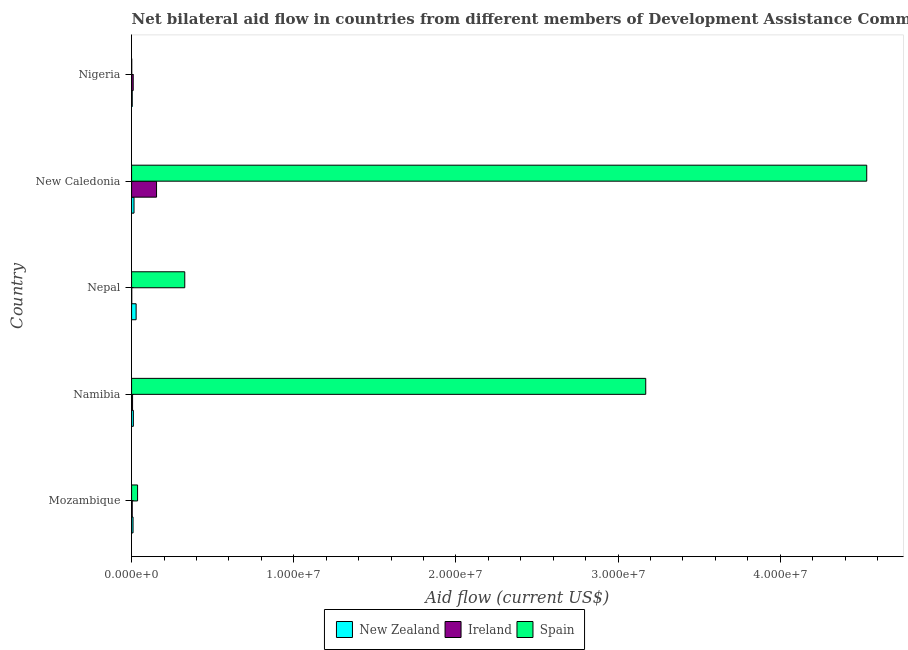How many groups of bars are there?
Your answer should be very brief. 5. What is the label of the 2nd group of bars from the top?
Give a very brief answer. New Caledonia. In how many cases, is the number of bars for a given country not equal to the number of legend labels?
Provide a short and direct response. 0. What is the amount of aid provided by spain in Mozambique?
Your answer should be compact. 3.70e+05. Across all countries, what is the maximum amount of aid provided by spain?
Ensure brevity in your answer.  4.53e+07. Across all countries, what is the minimum amount of aid provided by spain?
Keep it short and to the point. 10000. In which country was the amount of aid provided by ireland maximum?
Your answer should be compact. New Caledonia. In which country was the amount of aid provided by new zealand minimum?
Provide a succinct answer. Nigeria. What is the total amount of aid provided by spain in the graph?
Ensure brevity in your answer.  8.07e+07. What is the difference between the amount of aid provided by spain in Namibia and that in Nepal?
Give a very brief answer. 2.84e+07. What is the difference between the amount of aid provided by ireland in Nigeria and the amount of aid provided by new zealand in Namibia?
Make the answer very short. -10000. What is the average amount of aid provided by ireland per country?
Your answer should be compact. 3.50e+05. What is the difference between the amount of aid provided by ireland and amount of aid provided by new zealand in New Caledonia?
Make the answer very short. 1.39e+06. In how many countries, is the amount of aid provided by ireland greater than 20000000 US$?
Give a very brief answer. 0. Is the amount of aid provided by ireland in Mozambique less than that in Nigeria?
Your answer should be very brief. Yes. What is the difference between the highest and the lowest amount of aid provided by new zealand?
Keep it short and to the point. 2.40e+05. In how many countries, is the amount of aid provided by ireland greater than the average amount of aid provided by ireland taken over all countries?
Offer a very short reply. 1. Is the sum of the amount of aid provided by spain in Nepal and Nigeria greater than the maximum amount of aid provided by ireland across all countries?
Make the answer very short. Yes. What does the 3rd bar from the bottom in Nepal represents?
Your answer should be compact. Spain. How many bars are there?
Make the answer very short. 15. Are all the bars in the graph horizontal?
Give a very brief answer. Yes. Are the values on the major ticks of X-axis written in scientific E-notation?
Keep it short and to the point. Yes. Does the graph contain any zero values?
Give a very brief answer. No. Does the graph contain grids?
Ensure brevity in your answer.  No. Where does the legend appear in the graph?
Your answer should be very brief. Bottom center. What is the title of the graph?
Ensure brevity in your answer.  Net bilateral aid flow in countries from different members of Development Assistance Committee. What is the Aid flow (current US$) of Ireland in Mozambique?
Make the answer very short. 4.00e+04. What is the Aid flow (current US$) in Spain in Namibia?
Offer a terse response. 3.17e+07. What is the Aid flow (current US$) in Spain in Nepal?
Offer a very short reply. 3.28e+06. What is the Aid flow (current US$) of Ireland in New Caledonia?
Offer a terse response. 1.54e+06. What is the Aid flow (current US$) in Spain in New Caledonia?
Provide a short and direct response. 4.53e+07. What is the Aid flow (current US$) of Spain in Nigeria?
Ensure brevity in your answer.  10000. Across all countries, what is the maximum Aid flow (current US$) in New Zealand?
Offer a terse response. 2.80e+05. Across all countries, what is the maximum Aid flow (current US$) of Ireland?
Offer a very short reply. 1.54e+06. Across all countries, what is the maximum Aid flow (current US$) in Spain?
Offer a very short reply. 4.53e+07. Across all countries, what is the minimum Aid flow (current US$) of Spain?
Your response must be concise. 10000. What is the total Aid flow (current US$) in New Zealand in the graph?
Offer a terse response. 6.70e+05. What is the total Aid flow (current US$) of Ireland in the graph?
Your answer should be very brief. 1.75e+06. What is the total Aid flow (current US$) in Spain in the graph?
Provide a short and direct response. 8.07e+07. What is the difference between the Aid flow (current US$) of Spain in Mozambique and that in Namibia?
Offer a very short reply. -3.13e+07. What is the difference between the Aid flow (current US$) in Spain in Mozambique and that in Nepal?
Keep it short and to the point. -2.91e+06. What is the difference between the Aid flow (current US$) of Ireland in Mozambique and that in New Caledonia?
Offer a very short reply. -1.50e+06. What is the difference between the Aid flow (current US$) in Spain in Mozambique and that in New Caledonia?
Your answer should be very brief. -4.50e+07. What is the difference between the Aid flow (current US$) of New Zealand in Mozambique and that in Nigeria?
Your response must be concise. 5.00e+04. What is the difference between the Aid flow (current US$) of Ireland in Mozambique and that in Nigeria?
Your answer should be compact. -6.00e+04. What is the difference between the Aid flow (current US$) in New Zealand in Namibia and that in Nepal?
Your response must be concise. -1.70e+05. What is the difference between the Aid flow (current US$) of Spain in Namibia and that in Nepal?
Provide a succinct answer. 2.84e+07. What is the difference between the Aid flow (current US$) in Ireland in Namibia and that in New Caledonia?
Your response must be concise. -1.48e+06. What is the difference between the Aid flow (current US$) of Spain in Namibia and that in New Caledonia?
Ensure brevity in your answer.  -1.36e+07. What is the difference between the Aid flow (current US$) in New Zealand in Namibia and that in Nigeria?
Ensure brevity in your answer.  7.00e+04. What is the difference between the Aid flow (current US$) of Spain in Namibia and that in Nigeria?
Make the answer very short. 3.17e+07. What is the difference between the Aid flow (current US$) of Ireland in Nepal and that in New Caledonia?
Make the answer very short. -1.53e+06. What is the difference between the Aid flow (current US$) of Spain in Nepal and that in New Caledonia?
Give a very brief answer. -4.21e+07. What is the difference between the Aid flow (current US$) in Spain in Nepal and that in Nigeria?
Ensure brevity in your answer.  3.27e+06. What is the difference between the Aid flow (current US$) of New Zealand in New Caledonia and that in Nigeria?
Your answer should be very brief. 1.10e+05. What is the difference between the Aid flow (current US$) in Ireland in New Caledonia and that in Nigeria?
Keep it short and to the point. 1.44e+06. What is the difference between the Aid flow (current US$) of Spain in New Caledonia and that in Nigeria?
Provide a succinct answer. 4.53e+07. What is the difference between the Aid flow (current US$) of New Zealand in Mozambique and the Aid flow (current US$) of Ireland in Namibia?
Your response must be concise. 3.00e+04. What is the difference between the Aid flow (current US$) in New Zealand in Mozambique and the Aid flow (current US$) in Spain in Namibia?
Provide a short and direct response. -3.16e+07. What is the difference between the Aid flow (current US$) in Ireland in Mozambique and the Aid flow (current US$) in Spain in Namibia?
Make the answer very short. -3.17e+07. What is the difference between the Aid flow (current US$) of New Zealand in Mozambique and the Aid flow (current US$) of Ireland in Nepal?
Offer a terse response. 8.00e+04. What is the difference between the Aid flow (current US$) of New Zealand in Mozambique and the Aid flow (current US$) of Spain in Nepal?
Offer a very short reply. -3.19e+06. What is the difference between the Aid flow (current US$) of Ireland in Mozambique and the Aid flow (current US$) of Spain in Nepal?
Offer a very short reply. -3.24e+06. What is the difference between the Aid flow (current US$) in New Zealand in Mozambique and the Aid flow (current US$) in Ireland in New Caledonia?
Your answer should be compact. -1.45e+06. What is the difference between the Aid flow (current US$) of New Zealand in Mozambique and the Aid flow (current US$) of Spain in New Caledonia?
Provide a short and direct response. -4.52e+07. What is the difference between the Aid flow (current US$) in Ireland in Mozambique and the Aid flow (current US$) in Spain in New Caledonia?
Provide a short and direct response. -4.53e+07. What is the difference between the Aid flow (current US$) of New Zealand in Mozambique and the Aid flow (current US$) of Ireland in Nigeria?
Offer a terse response. -10000. What is the difference between the Aid flow (current US$) of New Zealand in Mozambique and the Aid flow (current US$) of Spain in Nigeria?
Give a very brief answer. 8.00e+04. What is the difference between the Aid flow (current US$) of New Zealand in Namibia and the Aid flow (current US$) of Ireland in Nepal?
Offer a terse response. 1.00e+05. What is the difference between the Aid flow (current US$) in New Zealand in Namibia and the Aid flow (current US$) in Spain in Nepal?
Your response must be concise. -3.17e+06. What is the difference between the Aid flow (current US$) in Ireland in Namibia and the Aid flow (current US$) in Spain in Nepal?
Give a very brief answer. -3.22e+06. What is the difference between the Aid flow (current US$) of New Zealand in Namibia and the Aid flow (current US$) of Ireland in New Caledonia?
Ensure brevity in your answer.  -1.43e+06. What is the difference between the Aid flow (current US$) in New Zealand in Namibia and the Aid flow (current US$) in Spain in New Caledonia?
Ensure brevity in your answer.  -4.52e+07. What is the difference between the Aid flow (current US$) of Ireland in Namibia and the Aid flow (current US$) of Spain in New Caledonia?
Make the answer very short. -4.53e+07. What is the difference between the Aid flow (current US$) in New Zealand in Nepal and the Aid flow (current US$) in Ireland in New Caledonia?
Provide a short and direct response. -1.26e+06. What is the difference between the Aid flow (current US$) of New Zealand in Nepal and the Aid flow (current US$) of Spain in New Caledonia?
Offer a terse response. -4.51e+07. What is the difference between the Aid flow (current US$) in Ireland in Nepal and the Aid flow (current US$) in Spain in New Caledonia?
Keep it short and to the point. -4.53e+07. What is the difference between the Aid flow (current US$) in New Zealand in Nepal and the Aid flow (current US$) in Ireland in Nigeria?
Offer a terse response. 1.80e+05. What is the difference between the Aid flow (current US$) in New Zealand in Nepal and the Aid flow (current US$) in Spain in Nigeria?
Make the answer very short. 2.70e+05. What is the difference between the Aid flow (current US$) in Ireland in Nepal and the Aid flow (current US$) in Spain in Nigeria?
Make the answer very short. 0. What is the difference between the Aid flow (current US$) of New Zealand in New Caledonia and the Aid flow (current US$) of Ireland in Nigeria?
Keep it short and to the point. 5.00e+04. What is the difference between the Aid flow (current US$) of Ireland in New Caledonia and the Aid flow (current US$) of Spain in Nigeria?
Your answer should be very brief. 1.53e+06. What is the average Aid flow (current US$) in New Zealand per country?
Offer a terse response. 1.34e+05. What is the average Aid flow (current US$) of Spain per country?
Your answer should be very brief. 1.61e+07. What is the difference between the Aid flow (current US$) in New Zealand and Aid flow (current US$) in Ireland in Mozambique?
Your answer should be very brief. 5.00e+04. What is the difference between the Aid flow (current US$) of New Zealand and Aid flow (current US$) of Spain in Mozambique?
Give a very brief answer. -2.80e+05. What is the difference between the Aid flow (current US$) in Ireland and Aid flow (current US$) in Spain in Mozambique?
Offer a very short reply. -3.30e+05. What is the difference between the Aid flow (current US$) of New Zealand and Aid flow (current US$) of Spain in Namibia?
Offer a very short reply. -3.16e+07. What is the difference between the Aid flow (current US$) of Ireland and Aid flow (current US$) of Spain in Namibia?
Ensure brevity in your answer.  -3.16e+07. What is the difference between the Aid flow (current US$) in Ireland and Aid flow (current US$) in Spain in Nepal?
Make the answer very short. -3.27e+06. What is the difference between the Aid flow (current US$) in New Zealand and Aid flow (current US$) in Ireland in New Caledonia?
Keep it short and to the point. -1.39e+06. What is the difference between the Aid flow (current US$) of New Zealand and Aid flow (current US$) of Spain in New Caledonia?
Provide a short and direct response. -4.52e+07. What is the difference between the Aid flow (current US$) in Ireland and Aid flow (current US$) in Spain in New Caledonia?
Your response must be concise. -4.38e+07. What is the difference between the Aid flow (current US$) in New Zealand and Aid flow (current US$) in Ireland in Nigeria?
Keep it short and to the point. -6.00e+04. What is the ratio of the Aid flow (current US$) of New Zealand in Mozambique to that in Namibia?
Give a very brief answer. 0.82. What is the ratio of the Aid flow (current US$) of Spain in Mozambique to that in Namibia?
Your answer should be compact. 0.01. What is the ratio of the Aid flow (current US$) in New Zealand in Mozambique to that in Nepal?
Keep it short and to the point. 0.32. What is the ratio of the Aid flow (current US$) in Ireland in Mozambique to that in Nepal?
Ensure brevity in your answer.  4. What is the ratio of the Aid flow (current US$) of Spain in Mozambique to that in Nepal?
Ensure brevity in your answer.  0.11. What is the ratio of the Aid flow (current US$) in New Zealand in Mozambique to that in New Caledonia?
Ensure brevity in your answer.  0.6. What is the ratio of the Aid flow (current US$) in Ireland in Mozambique to that in New Caledonia?
Ensure brevity in your answer.  0.03. What is the ratio of the Aid flow (current US$) in Spain in Mozambique to that in New Caledonia?
Keep it short and to the point. 0.01. What is the ratio of the Aid flow (current US$) of New Zealand in Mozambique to that in Nigeria?
Ensure brevity in your answer.  2.25. What is the ratio of the Aid flow (current US$) in Ireland in Mozambique to that in Nigeria?
Offer a very short reply. 0.4. What is the ratio of the Aid flow (current US$) of Spain in Mozambique to that in Nigeria?
Your answer should be very brief. 37. What is the ratio of the Aid flow (current US$) in New Zealand in Namibia to that in Nepal?
Keep it short and to the point. 0.39. What is the ratio of the Aid flow (current US$) of Ireland in Namibia to that in Nepal?
Provide a short and direct response. 6. What is the ratio of the Aid flow (current US$) of Spain in Namibia to that in Nepal?
Your response must be concise. 9.67. What is the ratio of the Aid flow (current US$) of New Zealand in Namibia to that in New Caledonia?
Your answer should be compact. 0.73. What is the ratio of the Aid flow (current US$) of Ireland in Namibia to that in New Caledonia?
Your answer should be compact. 0.04. What is the ratio of the Aid flow (current US$) of Spain in Namibia to that in New Caledonia?
Ensure brevity in your answer.  0.7. What is the ratio of the Aid flow (current US$) of New Zealand in Namibia to that in Nigeria?
Provide a short and direct response. 2.75. What is the ratio of the Aid flow (current US$) of Ireland in Namibia to that in Nigeria?
Provide a short and direct response. 0.6. What is the ratio of the Aid flow (current US$) in Spain in Namibia to that in Nigeria?
Provide a short and direct response. 3171. What is the ratio of the Aid flow (current US$) of New Zealand in Nepal to that in New Caledonia?
Give a very brief answer. 1.87. What is the ratio of the Aid flow (current US$) of Ireland in Nepal to that in New Caledonia?
Provide a succinct answer. 0.01. What is the ratio of the Aid flow (current US$) in Spain in Nepal to that in New Caledonia?
Give a very brief answer. 0.07. What is the ratio of the Aid flow (current US$) in Spain in Nepal to that in Nigeria?
Give a very brief answer. 328. What is the ratio of the Aid flow (current US$) of New Zealand in New Caledonia to that in Nigeria?
Give a very brief answer. 3.75. What is the ratio of the Aid flow (current US$) of Spain in New Caledonia to that in Nigeria?
Give a very brief answer. 4534. What is the difference between the highest and the second highest Aid flow (current US$) of Ireland?
Keep it short and to the point. 1.44e+06. What is the difference between the highest and the second highest Aid flow (current US$) in Spain?
Ensure brevity in your answer.  1.36e+07. What is the difference between the highest and the lowest Aid flow (current US$) in Ireland?
Provide a succinct answer. 1.53e+06. What is the difference between the highest and the lowest Aid flow (current US$) of Spain?
Your answer should be compact. 4.53e+07. 